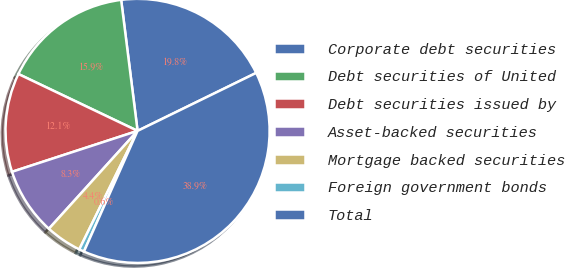<chart> <loc_0><loc_0><loc_500><loc_500><pie_chart><fcel>Corporate debt securities<fcel>Debt securities of United<fcel>Debt securities issued by<fcel>Asset-backed securities<fcel>Mortgage backed securities<fcel>Foreign government bonds<fcel>Total<nl><fcel>19.75%<fcel>15.93%<fcel>12.1%<fcel>8.27%<fcel>4.44%<fcel>0.62%<fcel>38.89%<nl></chart> 